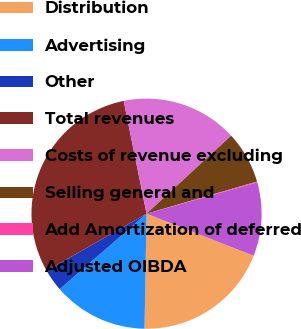<chart> <loc_0><loc_0><loc_500><loc_500><pie_chart><fcel>Distribution<fcel>Advertising<fcel>Other<fcel>Total revenues<fcel>Costs of revenue excluding<fcel>Selling general and<fcel>Add Amortization of deferred<fcel>Adjusted OIBDA<nl><fcel>19.32%<fcel>13.34%<fcel>3.12%<fcel>30.07%<fcel>16.33%<fcel>7.35%<fcel>0.13%<fcel>10.34%<nl></chart> 